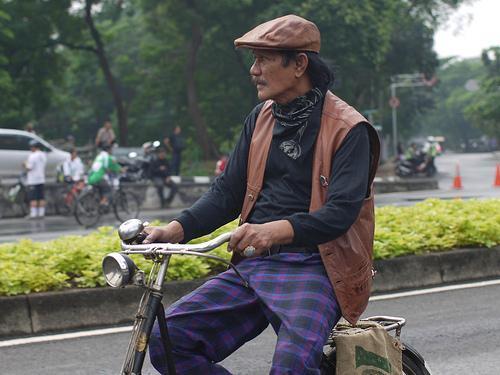How many hats is the man wearing?
Give a very brief answer. 1. 